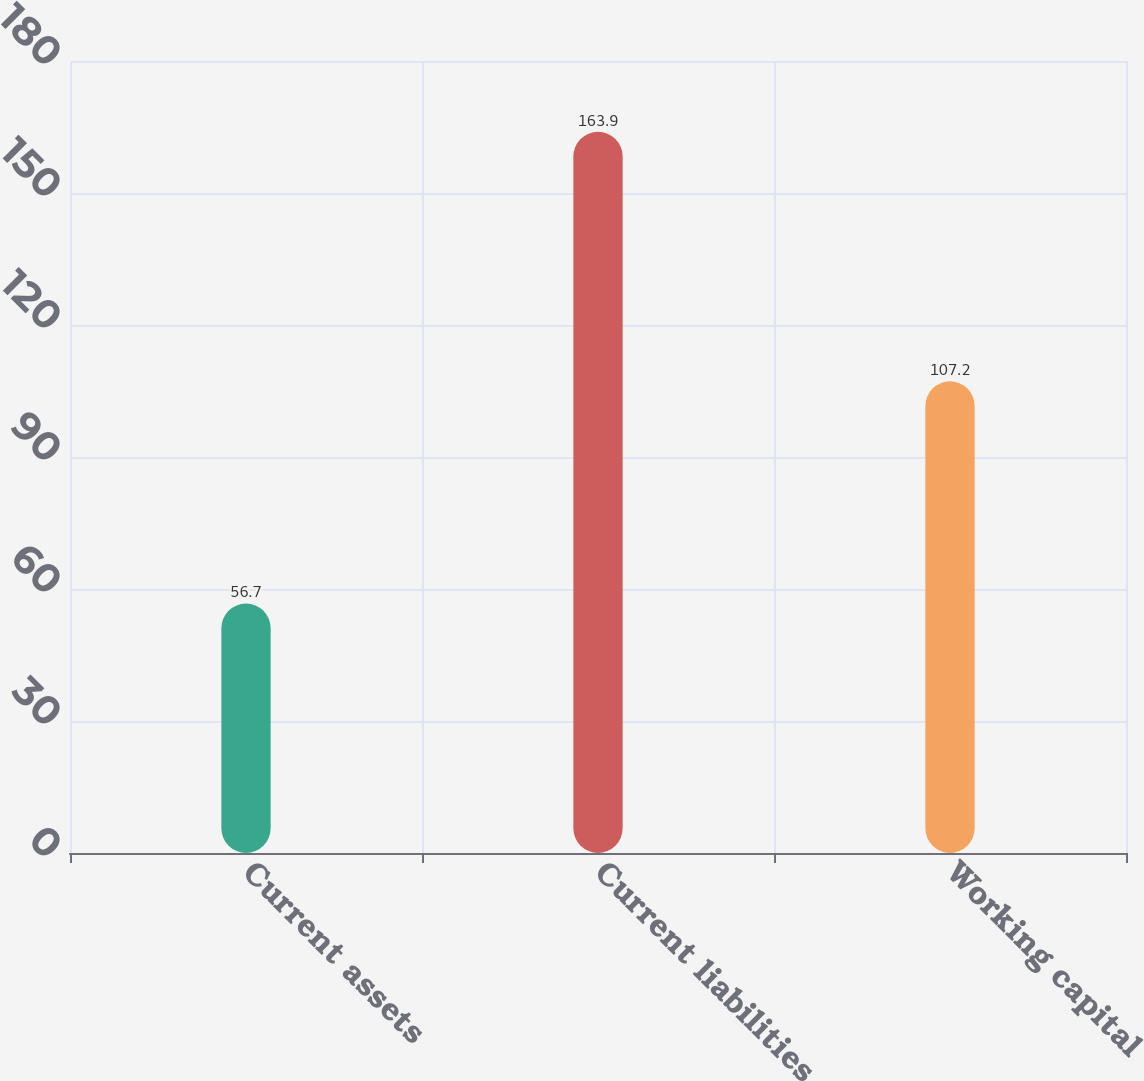Convert chart to OTSL. <chart><loc_0><loc_0><loc_500><loc_500><bar_chart><fcel>Current assets<fcel>Current liabilities<fcel>Working capital<nl><fcel>56.7<fcel>163.9<fcel>107.2<nl></chart> 